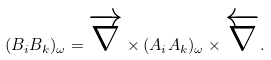<formula> <loc_0><loc_0><loc_500><loc_500>( B _ { i } B _ { k } ) _ { \omega } = \overrightarrow { \nabla } \times ( A _ { i } A _ { k } ) _ { \omega } \times \overleftarrow { \nabla } .</formula> 